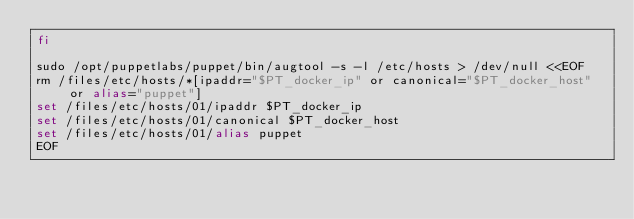<code> <loc_0><loc_0><loc_500><loc_500><_Bash_>fi

sudo /opt/puppetlabs/puppet/bin/augtool -s -l /etc/hosts > /dev/null <<EOF
rm /files/etc/hosts/*[ipaddr="$PT_docker_ip" or canonical="$PT_docker_host" or alias="puppet"]
set /files/etc/hosts/01/ipaddr $PT_docker_ip
set /files/etc/hosts/01/canonical $PT_docker_host
set /files/etc/hosts/01/alias puppet
EOF
</code> 